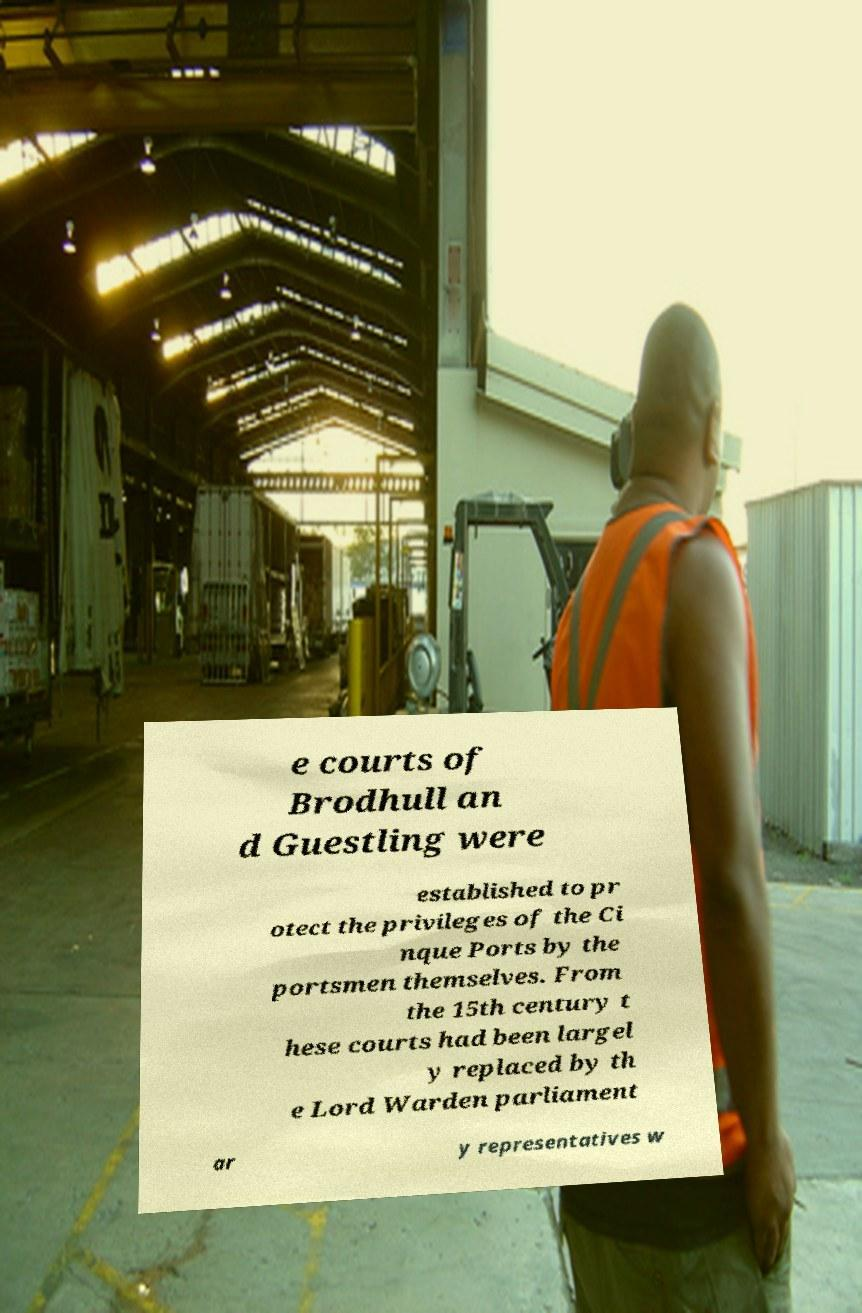Could you assist in decoding the text presented in this image and type it out clearly? e courts of Brodhull an d Guestling were established to pr otect the privileges of the Ci nque Ports by the portsmen themselves. From the 15th century t hese courts had been largel y replaced by th e Lord Warden parliament ar y representatives w 